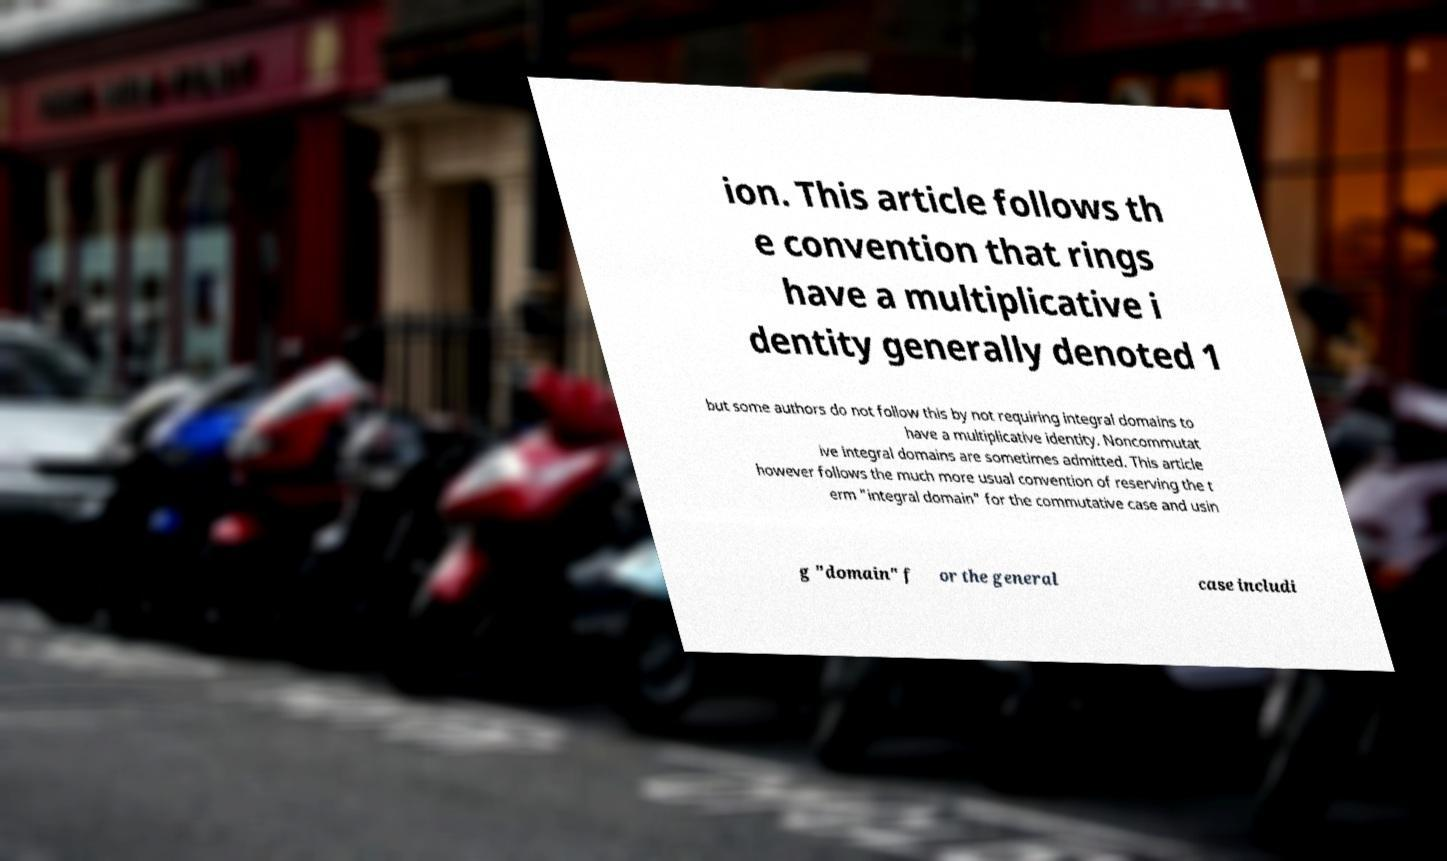Could you assist in decoding the text presented in this image and type it out clearly? ion. This article follows th e convention that rings have a multiplicative i dentity generally denoted 1 but some authors do not follow this by not requiring integral domains to have a multiplicative identity. Noncommutat ive integral domains are sometimes admitted. This article however follows the much more usual convention of reserving the t erm "integral domain" for the commutative case and usin g "domain" f or the general case includi 